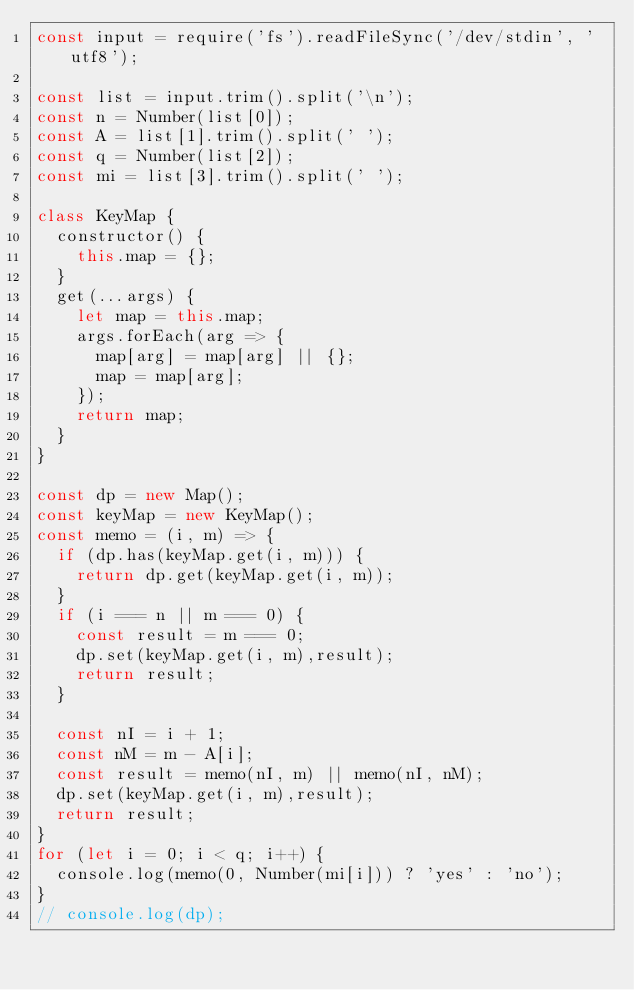<code> <loc_0><loc_0><loc_500><loc_500><_JavaScript_>const input = require('fs').readFileSync('/dev/stdin', 'utf8');

const list = input.trim().split('\n');
const n = Number(list[0]);
const A = list[1].trim().split(' ');
const q = Number(list[2]);
const mi = list[3].trim().split(' ');

class KeyMap {
  constructor() {
    this.map = {};
  }
  get(...args) {
    let map = this.map;
    args.forEach(arg => {
      map[arg] = map[arg] || {};
      map = map[arg];
    });
    return map;
  }
}

const dp = new Map();
const keyMap = new KeyMap();
const memo = (i, m) => {
  if (dp.has(keyMap.get(i, m))) {
    return dp.get(keyMap.get(i, m));
  }
  if (i === n || m === 0) {
    const result = m === 0;
    dp.set(keyMap.get(i, m),result);
    return result;
  }

  const nI = i + 1;
  const nM = m - A[i];
  const result = memo(nI, m) || memo(nI, nM);
  dp.set(keyMap.get(i, m),result);
  return result;
}
for (let i = 0; i < q; i++) {
  console.log(memo(0, Number(mi[i])) ? 'yes' : 'no');
}
// console.log(dp);
</code> 